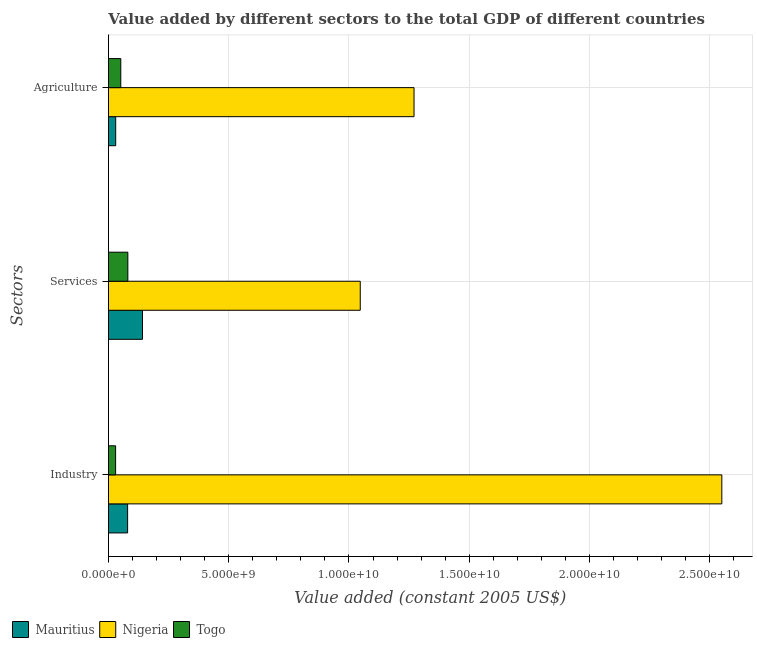How many groups of bars are there?
Provide a succinct answer. 3. Are the number of bars on each tick of the Y-axis equal?
Keep it short and to the point. Yes. How many bars are there on the 3rd tick from the bottom?
Your answer should be very brief. 3. What is the label of the 1st group of bars from the top?
Provide a succinct answer. Agriculture. What is the value added by industrial sector in Mauritius?
Your response must be concise. 7.98e+08. Across all countries, what is the maximum value added by industrial sector?
Offer a terse response. 2.55e+1. Across all countries, what is the minimum value added by services?
Ensure brevity in your answer.  8.07e+08. In which country was the value added by services maximum?
Your answer should be compact. Nigeria. In which country was the value added by services minimum?
Your answer should be very brief. Togo. What is the total value added by agricultural sector in the graph?
Provide a succinct answer. 1.35e+1. What is the difference between the value added by agricultural sector in Togo and that in Mauritius?
Make the answer very short. 2.12e+08. What is the difference between the value added by services in Togo and the value added by industrial sector in Nigeria?
Make the answer very short. -2.47e+1. What is the average value added by agricultural sector per country?
Your answer should be compact. 4.51e+09. What is the difference between the value added by industrial sector and value added by services in Mauritius?
Keep it short and to the point. -6.18e+08. In how many countries, is the value added by industrial sector greater than 9000000000 US$?
Keep it short and to the point. 1. What is the ratio of the value added by services in Nigeria to that in Togo?
Offer a terse response. 12.97. What is the difference between the highest and the second highest value added by agricultural sector?
Give a very brief answer. 1.22e+1. What is the difference between the highest and the lowest value added by agricultural sector?
Provide a short and direct response. 1.24e+1. In how many countries, is the value added by industrial sector greater than the average value added by industrial sector taken over all countries?
Offer a very short reply. 1. What does the 3rd bar from the top in Industry represents?
Your response must be concise. Mauritius. What does the 2nd bar from the bottom in Industry represents?
Your answer should be compact. Nigeria. Is it the case that in every country, the sum of the value added by industrial sector and value added by services is greater than the value added by agricultural sector?
Your response must be concise. Yes. How many bars are there?
Keep it short and to the point. 9. What is the difference between two consecutive major ticks on the X-axis?
Keep it short and to the point. 5.00e+09. Are the values on the major ticks of X-axis written in scientific E-notation?
Make the answer very short. Yes. Where does the legend appear in the graph?
Your answer should be compact. Bottom left. How many legend labels are there?
Keep it short and to the point. 3. How are the legend labels stacked?
Your response must be concise. Horizontal. What is the title of the graph?
Your response must be concise. Value added by different sectors to the total GDP of different countries. What is the label or title of the X-axis?
Offer a very short reply. Value added (constant 2005 US$). What is the label or title of the Y-axis?
Offer a terse response. Sectors. What is the Value added (constant 2005 US$) of Mauritius in Industry?
Offer a very short reply. 7.98e+08. What is the Value added (constant 2005 US$) in Nigeria in Industry?
Give a very brief answer. 2.55e+1. What is the Value added (constant 2005 US$) in Togo in Industry?
Provide a short and direct response. 2.99e+08. What is the Value added (constant 2005 US$) of Mauritius in Services?
Make the answer very short. 1.42e+09. What is the Value added (constant 2005 US$) in Nigeria in Services?
Offer a terse response. 1.05e+1. What is the Value added (constant 2005 US$) in Togo in Services?
Keep it short and to the point. 8.07e+08. What is the Value added (constant 2005 US$) of Mauritius in Agriculture?
Your answer should be very brief. 3.02e+08. What is the Value added (constant 2005 US$) in Nigeria in Agriculture?
Offer a terse response. 1.27e+1. What is the Value added (constant 2005 US$) of Togo in Agriculture?
Offer a very short reply. 5.14e+08. Across all Sectors, what is the maximum Value added (constant 2005 US$) in Mauritius?
Make the answer very short. 1.42e+09. Across all Sectors, what is the maximum Value added (constant 2005 US$) in Nigeria?
Provide a short and direct response. 2.55e+1. Across all Sectors, what is the maximum Value added (constant 2005 US$) in Togo?
Offer a terse response. 8.07e+08. Across all Sectors, what is the minimum Value added (constant 2005 US$) in Mauritius?
Make the answer very short. 3.02e+08. Across all Sectors, what is the minimum Value added (constant 2005 US$) of Nigeria?
Your answer should be very brief. 1.05e+1. Across all Sectors, what is the minimum Value added (constant 2005 US$) in Togo?
Give a very brief answer. 2.99e+08. What is the total Value added (constant 2005 US$) in Mauritius in the graph?
Give a very brief answer. 2.51e+09. What is the total Value added (constant 2005 US$) in Nigeria in the graph?
Provide a succinct answer. 4.87e+1. What is the total Value added (constant 2005 US$) of Togo in the graph?
Offer a terse response. 1.62e+09. What is the difference between the Value added (constant 2005 US$) of Mauritius in Industry and that in Services?
Your response must be concise. -6.18e+08. What is the difference between the Value added (constant 2005 US$) in Nigeria in Industry and that in Services?
Keep it short and to the point. 1.50e+1. What is the difference between the Value added (constant 2005 US$) in Togo in Industry and that in Services?
Offer a very short reply. -5.09e+08. What is the difference between the Value added (constant 2005 US$) in Mauritius in Industry and that in Agriculture?
Give a very brief answer. 4.96e+08. What is the difference between the Value added (constant 2005 US$) of Nigeria in Industry and that in Agriculture?
Keep it short and to the point. 1.28e+1. What is the difference between the Value added (constant 2005 US$) of Togo in Industry and that in Agriculture?
Make the answer very short. -2.15e+08. What is the difference between the Value added (constant 2005 US$) in Mauritius in Services and that in Agriculture?
Give a very brief answer. 1.11e+09. What is the difference between the Value added (constant 2005 US$) of Nigeria in Services and that in Agriculture?
Offer a terse response. -2.24e+09. What is the difference between the Value added (constant 2005 US$) in Togo in Services and that in Agriculture?
Provide a succinct answer. 2.93e+08. What is the difference between the Value added (constant 2005 US$) of Mauritius in Industry and the Value added (constant 2005 US$) of Nigeria in Services?
Provide a succinct answer. -9.67e+09. What is the difference between the Value added (constant 2005 US$) in Mauritius in Industry and the Value added (constant 2005 US$) in Togo in Services?
Keep it short and to the point. -9.67e+06. What is the difference between the Value added (constant 2005 US$) in Nigeria in Industry and the Value added (constant 2005 US$) in Togo in Services?
Your response must be concise. 2.47e+1. What is the difference between the Value added (constant 2005 US$) in Mauritius in Industry and the Value added (constant 2005 US$) in Nigeria in Agriculture?
Provide a succinct answer. -1.19e+1. What is the difference between the Value added (constant 2005 US$) in Mauritius in Industry and the Value added (constant 2005 US$) in Togo in Agriculture?
Keep it short and to the point. 2.84e+08. What is the difference between the Value added (constant 2005 US$) of Nigeria in Industry and the Value added (constant 2005 US$) of Togo in Agriculture?
Offer a very short reply. 2.50e+1. What is the difference between the Value added (constant 2005 US$) in Mauritius in Services and the Value added (constant 2005 US$) in Nigeria in Agriculture?
Your answer should be compact. -1.13e+1. What is the difference between the Value added (constant 2005 US$) in Mauritius in Services and the Value added (constant 2005 US$) in Togo in Agriculture?
Ensure brevity in your answer.  9.02e+08. What is the difference between the Value added (constant 2005 US$) of Nigeria in Services and the Value added (constant 2005 US$) of Togo in Agriculture?
Give a very brief answer. 9.96e+09. What is the average Value added (constant 2005 US$) in Mauritius per Sectors?
Offer a terse response. 8.38e+08. What is the average Value added (constant 2005 US$) in Nigeria per Sectors?
Offer a very short reply. 1.62e+1. What is the average Value added (constant 2005 US$) of Togo per Sectors?
Keep it short and to the point. 5.40e+08. What is the difference between the Value added (constant 2005 US$) in Mauritius and Value added (constant 2005 US$) in Nigeria in Industry?
Offer a very short reply. -2.47e+1. What is the difference between the Value added (constant 2005 US$) of Mauritius and Value added (constant 2005 US$) of Togo in Industry?
Provide a succinct answer. 4.99e+08. What is the difference between the Value added (constant 2005 US$) in Nigeria and Value added (constant 2005 US$) in Togo in Industry?
Ensure brevity in your answer.  2.52e+1. What is the difference between the Value added (constant 2005 US$) of Mauritius and Value added (constant 2005 US$) of Nigeria in Services?
Provide a short and direct response. -9.05e+09. What is the difference between the Value added (constant 2005 US$) of Mauritius and Value added (constant 2005 US$) of Togo in Services?
Make the answer very short. 6.08e+08. What is the difference between the Value added (constant 2005 US$) of Nigeria and Value added (constant 2005 US$) of Togo in Services?
Keep it short and to the point. 9.66e+09. What is the difference between the Value added (constant 2005 US$) of Mauritius and Value added (constant 2005 US$) of Nigeria in Agriculture?
Make the answer very short. -1.24e+1. What is the difference between the Value added (constant 2005 US$) of Mauritius and Value added (constant 2005 US$) of Togo in Agriculture?
Make the answer very short. -2.12e+08. What is the difference between the Value added (constant 2005 US$) of Nigeria and Value added (constant 2005 US$) of Togo in Agriculture?
Your response must be concise. 1.22e+1. What is the ratio of the Value added (constant 2005 US$) of Mauritius in Industry to that in Services?
Give a very brief answer. 0.56. What is the ratio of the Value added (constant 2005 US$) of Nigeria in Industry to that in Services?
Offer a very short reply. 2.44. What is the ratio of the Value added (constant 2005 US$) of Togo in Industry to that in Services?
Offer a very short reply. 0.37. What is the ratio of the Value added (constant 2005 US$) of Mauritius in Industry to that in Agriculture?
Offer a terse response. 2.65. What is the ratio of the Value added (constant 2005 US$) of Nigeria in Industry to that in Agriculture?
Offer a terse response. 2.01. What is the ratio of the Value added (constant 2005 US$) in Togo in Industry to that in Agriculture?
Give a very brief answer. 0.58. What is the ratio of the Value added (constant 2005 US$) of Mauritius in Services to that in Agriculture?
Make the answer very short. 4.69. What is the ratio of the Value added (constant 2005 US$) of Nigeria in Services to that in Agriculture?
Your response must be concise. 0.82. What is the ratio of the Value added (constant 2005 US$) in Togo in Services to that in Agriculture?
Provide a short and direct response. 1.57. What is the difference between the highest and the second highest Value added (constant 2005 US$) in Mauritius?
Your answer should be very brief. 6.18e+08. What is the difference between the highest and the second highest Value added (constant 2005 US$) of Nigeria?
Your answer should be very brief. 1.28e+1. What is the difference between the highest and the second highest Value added (constant 2005 US$) in Togo?
Give a very brief answer. 2.93e+08. What is the difference between the highest and the lowest Value added (constant 2005 US$) of Mauritius?
Offer a terse response. 1.11e+09. What is the difference between the highest and the lowest Value added (constant 2005 US$) in Nigeria?
Ensure brevity in your answer.  1.50e+1. What is the difference between the highest and the lowest Value added (constant 2005 US$) in Togo?
Your answer should be compact. 5.09e+08. 